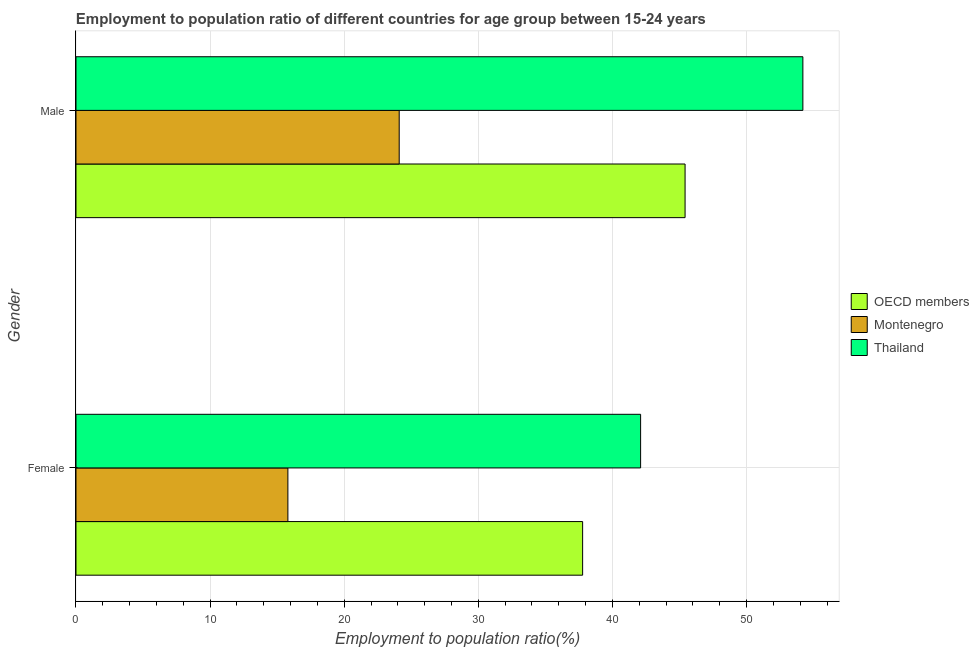How many groups of bars are there?
Provide a succinct answer. 2. Are the number of bars per tick equal to the number of legend labels?
Make the answer very short. Yes. Are the number of bars on each tick of the Y-axis equal?
Provide a succinct answer. Yes. How many bars are there on the 2nd tick from the top?
Your response must be concise. 3. What is the employment to population ratio(female) in Montenegro?
Your answer should be very brief. 15.8. Across all countries, what is the maximum employment to population ratio(female)?
Make the answer very short. 42.1. Across all countries, what is the minimum employment to population ratio(female)?
Provide a short and direct response. 15.8. In which country was the employment to population ratio(male) maximum?
Offer a very short reply. Thailand. In which country was the employment to population ratio(male) minimum?
Provide a succinct answer. Montenegro. What is the total employment to population ratio(male) in the graph?
Provide a succinct answer. 123.72. What is the difference between the employment to population ratio(male) in Thailand and that in OECD members?
Offer a terse response. 8.78. What is the difference between the employment to population ratio(male) in Thailand and the employment to population ratio(female) in OECD members?
Provide a succinct answer. 16.42. What is the average employment to population ratio(female) per country?
Keep it short and to the point. 31.89. What is the difference between the employment to population ratio(male) and employment to population ratio(female) in OECD members?
Your answer should be very brief. 7.64. What is the ratio of the employment to population ratio(female) in Montenegro to that in OECD members?
Make the answer very short. 0.42. Is the employment to population ratio(female) in Montenegro less than that in Thailand?
Provide a short and direct response. Yes. What does the 2nd bar from the top in Male represents?
Your response must be concise. Montenegro. What does the 1st bar from the bottom in Female represents?
Ensure brevity in your answer.  OECD members. How many bars are there?
Give a very brief answer. 6. How many countries are there in the graph?
Your answer should be compact. 3. Are the values on the major ticks of X-axis written in scientific E-notation?
Keep it short and to the point. No. Does the graph contain any zero values?
Your answer should be compact. No. How are the legend labels stacked?
Offer a very short reply. Vertical. What is the title of the graph?
Keep it short and to the point. Employment to population ratio of different countries for age group between 15-24 years. What is the label or title of the X-axis?
Your answer should be very brief. Employment to population ratio(%). What is the label or title of the Y-axis?
Provide a short and direct response. Gender. What is the Employment to population ratio(%) in OECD members in Female?
Provide a short and direct response. 37.78. What is the Employment to population ratio(%) in Montenegro in Female?
Make the answer very short. 15.8. What is the Employment to population ratio(%) of Thailand in Female?
Give a very brief answer. 42.1. What is the Employment to population ratio(%) of OECD members in Male?
Offer a terse response. 45.42. What is the Employment to population ratio(%) of Montenegro in Male?
Your response must be concise. 24.1. What is the Employment to population ratio(%) in Thailand in Male?
Keep it short and to the point. 54.2. Across all Gender, what is the maximum Employment to population ratio(%) of OECD members?
Provide a succinct answer. 45.42. Across all Gender, what is the maximum Employment to population ratio(%) of Montenegro?
Offer a terse response. 24.1. Across all Gender, what is the maximum Employment to population ratio(%) of Thailand?
Your answer should be very brief. 54.2. Across all Gender, what is the minimum Employment to population ratio(%) in OECD members?
Ensure brevity in your answer.  37.78. Across all Gender, what is the minimum Employment to population ratio(%) of Montenegro?
Your answer should be compact. 15.8. Across all Gender, what is the minimum Employment to population ratio(%) in Thailand?
Offer a very short reply. 42.1. What is the total Employment to population ratio(%) of OECD members in the graph?
Your answer should be compact. 83.19. What is the total Employment to population ratio(%) in Montenegro in the graph?
Give a very brief answer. 39.9. What is the total Employment to population ratio(%) in Thailand in the graph?
Provide a succinct answer. 96.3. What is the difference between the Employment to population ratio(%) in OECD members in Female and that in Male?
Give a very brief answer. -7.64. What is the difference between the Employment to population ratio(%) in Thailand in Female and that in Male?
Provide a succinct answer. -12.1. What is the difference between the Employment to population ratio(%) of OECD members in Female and the Employment to population ratio(%) of Montenegro in Male?
Provide a succinct answer. 13.68. What is the difference between the Employment to population ratio(%) of OECD members in Female and the Employment to population ratio(%) of Thailand in Male?
Offer a very short reply. -16.42. What is the difference between the Employment to population ratio(%) in Montenegro in Female and the Employment to population ratio(%) in Thailand in Male?
Ensure brevity in your answer.  -38.4. What is the average Employment to population ratio(%) of OECD members per Gender?
Ensure brevity in your answer.  41.6. What is the average Employment to population ratio(%) in Montenegro per Gender?
Your answer should be compact. 19.95. What is the average Employment to population ratio(%) of Thailand per Gender?
Offer a terse response. 48.15. What is the difference between the Employment to population ratio(%) of OECD members and Employment to population ratio(%) of Montenegro in Female?
Make the answer very short. 21.98. What is the difference between the Employment to population ratio(%) in OECD members and Employment to population ratio(%) in Thailand in Female?
Provide a short and direct response. -4.32. What is the difference between the Employment to population ratio(%) of Montenegro and Employment to population ratio(%) of Thailand in Female?
Ensure brevity in your answer.  -26.3. What is the difference between the Employment to population ratio(%) in OECD members and Employment to population ratio(%) in Montenegro in Male?
Make the answer very short. 21.32. What is the difference between the Employment to population ratio(%) of OECD members and Employment to population ratio(%) of Thailand in Male?
Offer a very short reply. -8.78. What is the difference between the Employment to population ratio(%) of Montenegro and Employment to population ratio(%) of Thailand in Male?
Keep it short and to the point. -30.1. What is the ratio of the Employment to population ratio(%) in OECD members in Female to that in Male?
Offer a terse response. 0.83. What is the ratio of the Employment to population ratio(%) of Montenegro in Female to that in Male?
Your answer should be very brief. 0.66. What is the ratio of the Employment to population ratio(%) of Thailand in Female to that in Male?
Ensure brevity in your answer.  0.78. What is the difference between the highest and the second highest Employment to population ratio(%) of OECD members?
Keep it short and to the point. 7.64. What is the difference between the highest and the second highest Employment to population ratio(%) of Montenegro?
Your answer should be compact. 8.3. What is the difference between the highest and the second highest Employment to population ratio(%) in Thailand?
Your answer should be compact. 12.1. What is the difference between the highest and the lowest Employment to population ratio(%) in OECD members?
Provide a succinct answer. 7.64. What is the difference between the highest and the lowest Employment to population ratio(%) of Montenegro?
Make the answer very short. 8.3. What is the difference between the highest and the lowest Employment to population ratio(%) of Thailand?
Offer a terse response. 12.1. 